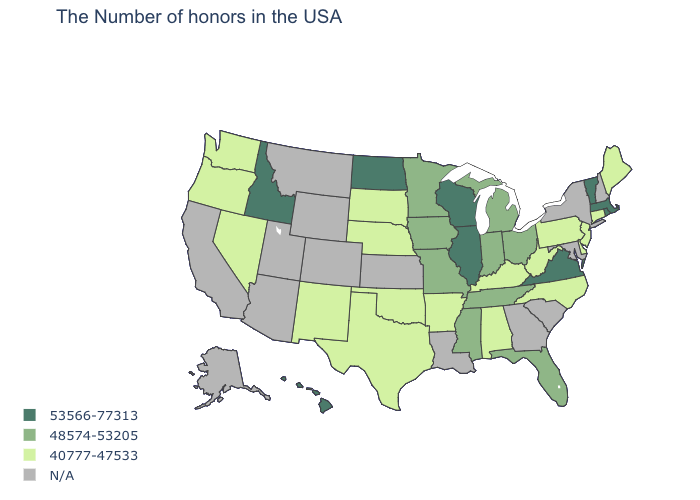Does Michigan have the lowest value in the USA?
Be succinct. No. Does the first symbol in the legend represent the smallest category?
Concise answer only. No. Which states have the lowest value in the Northeast?
Keep it brief. Maine, Connecticut, New Jersey, Pennsylvania. Which states have the lowest value in the MidWest?
Short answer required. Nebraska, South Dakota. What is the lowest value in the USA?
Concise answer only. 40777-47533. What is the value of Massachusetts?
Be succinct. 53566-77313. Name the states that have a value in the range 48574-53205?
Give a very brief answer. Ohio, Florida, Michigan, Indiana, Tennessee, Mississippi, Missouri, Minnesota, Iowa. Name the states that have a value in the range 53566-77313?
Write a very short answer. Massachusetts, Rhode Island, Vermont, Virginia, Wisconsin, Illinois, North Dakota, Idaho, Hawaii. What is the value of Wyoming?
Answer briefly. N/A. What is the value of Wyoming?
Give a very brief answer. N/A. Among the states that border Michigan , does Wisconsin have the lowest value?
Keep it brief. No. Does the map have missing data?
Answer briefly. Yes. What is the value of Hawaii?
Answer briefly. 53566-77313. 